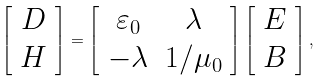Convert formula to latex. <formula><loc_0><loc_0><loc_500><loc_500>\left [ \begin{array} { c c c c } { D } \\ { H } \end{array} \right ] = \left [ \begin{array} { c c c c } { \varepsilon _ { 0 } } & \lambda \\ { - \lambda } & { 1 / \mu _ { 0 } } \end{array} \right ] \left [ \begin{array} { c c c c } { E } \\ { B } \end{array} \right ] ,</formula> 